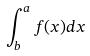<formula> <loc_0><loc_0><loc_500><loc_500>\int _ { b } ^ { a } f ( x ) d x</formula> 